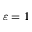<formula> <loc_0><loc_0><loc_500><loc_500>\varepsilon = 1</formula> 